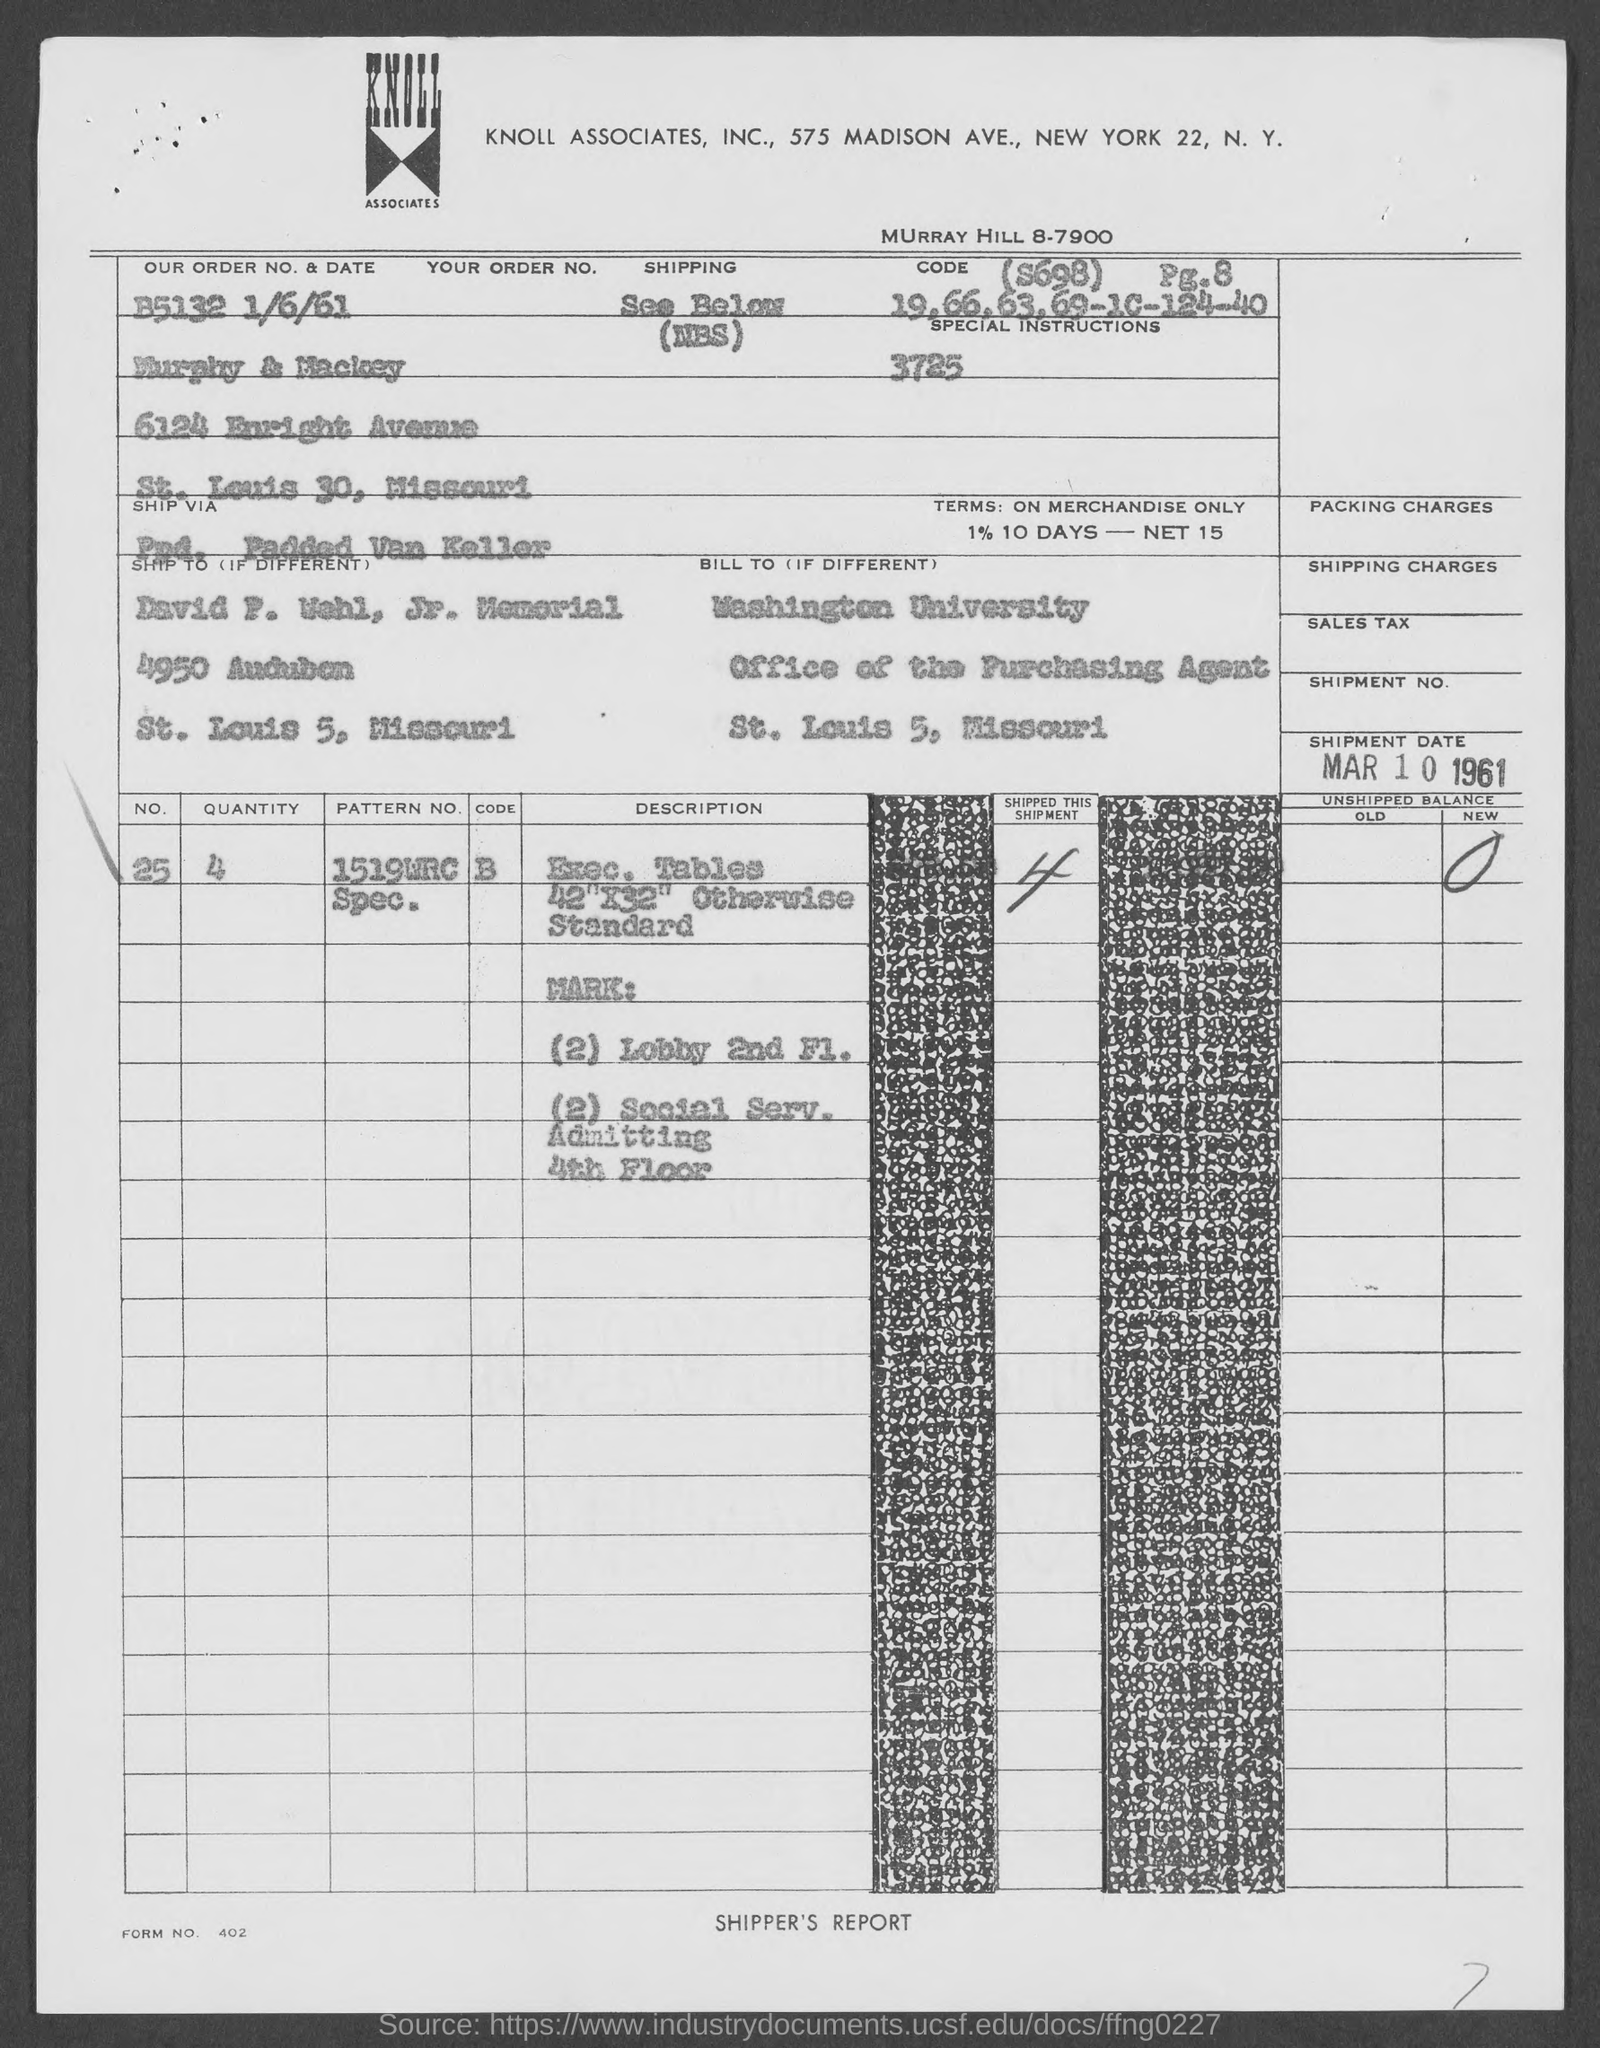What is the Order No. & date mentioned in the dcoument?
Ensure brevity in your answer.  B5132 1/6/61. Which university is mentioned in the billing address?
Keep it short and to the point. Washington university. What is the Form No. given in the document?
Offer a terse response. 402. What is the quantity of the item given in the document?
Offer a very short reply. 4. What is the Pattern No. of the item mentioned in the document?
Offer a terse response. 1519WRC Spec. 